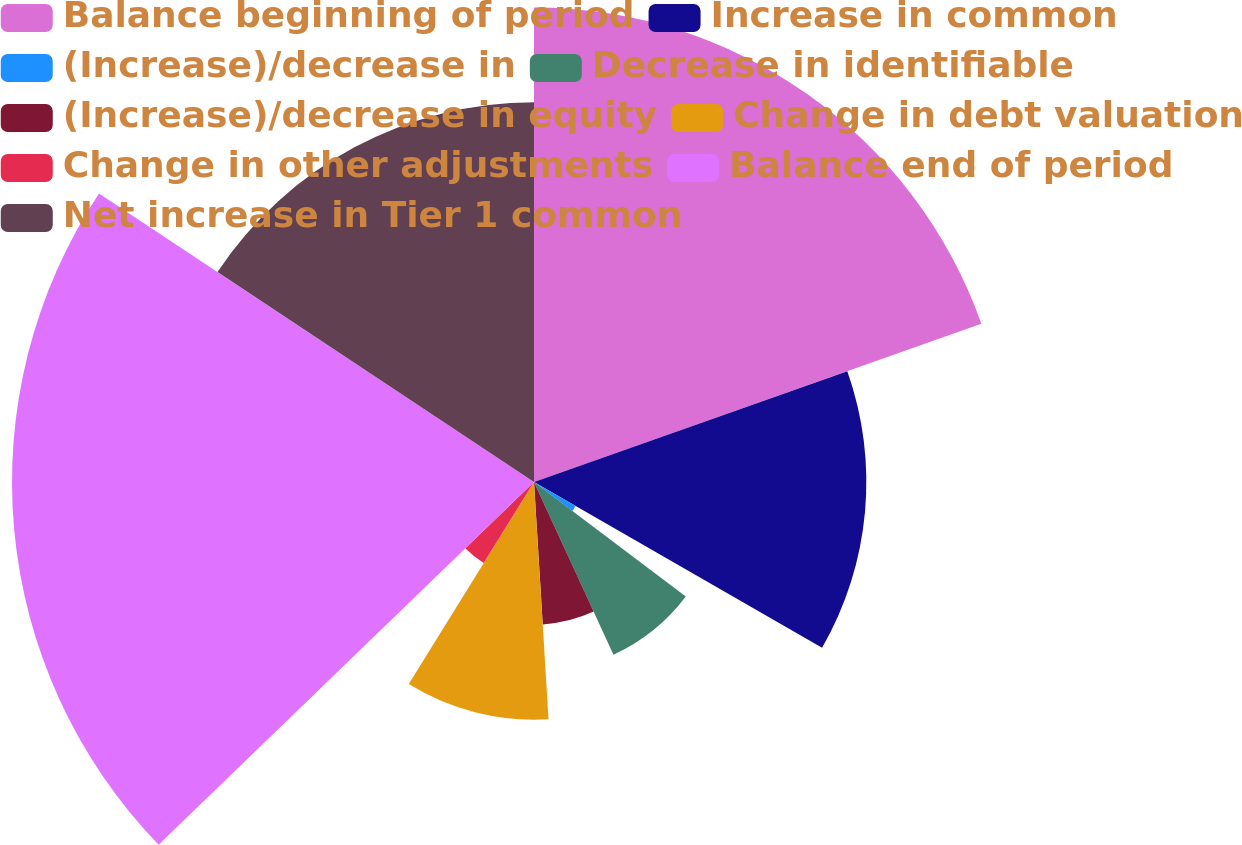Convert chart to OTSL. <chart><loc_0><loc_0><loc_500><loc_500><pie_chart><fcel>Balance beginning of period<fcel>Increase in common<fcel>(Increase)/decrease in<fcel>Decrease in identifiable<fcel>(Increase)/decrease in equity<fcel>Change in debt valuation<fcel>Change in other adjustments<fcel>Balance end of period<fcel>Net increase in Tier 1 common<nl><fcel>19.59%<fcel>13.72%<fcel>1.98%<fcel>7.85%<fcel>5.89%<fcel>9.81%<fcel>3.94%<fcel>21.55%<fcel>15.68%<nl></chart> 